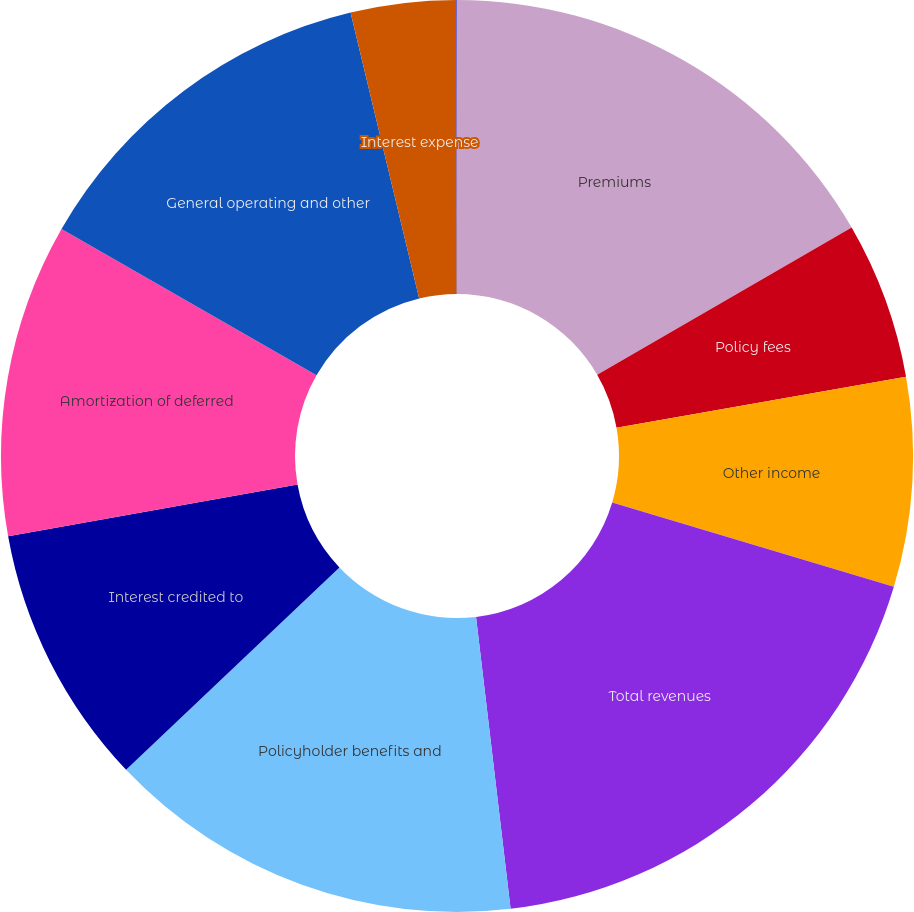Convert chart. <chart><loc_0><loc_0><loc_500><loc_500><pie_chart><fcel>Premiums<fcel>Policy fees<fcel>Other income<fcel>Total revenues<fcel>Policyholder benefits and<fcel>Interest credited to<fcel>Amortization of deferred<fcel>General operating and other<fcel>Interest expense<fcel>Loss on extinguishment of debt<nl><fcel>16.65%<fcel>5.57%<fcel>7.41%<fcel>18.5%<fcel>14.8%<fcel>9.26%<fcel>11.11%<fcel>12.96%<fcel>3.72%<fcel>0.03%<nl></chart> 